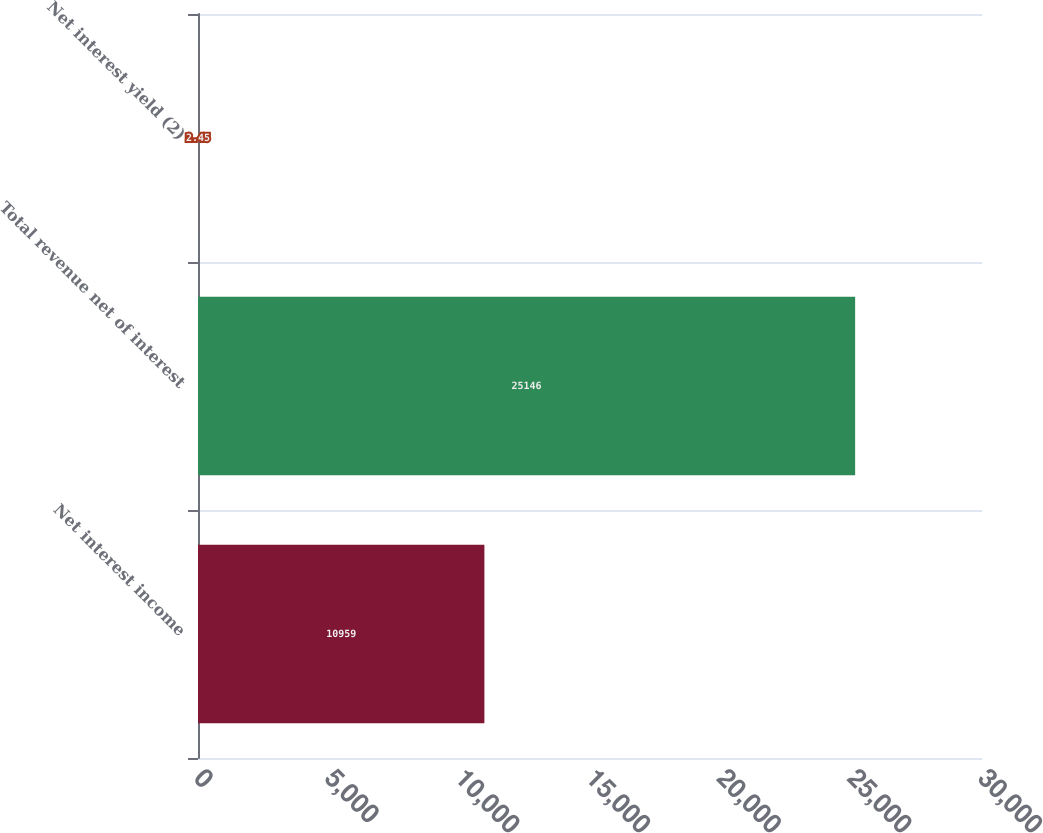Convert chart to OTSL. <chart><loc_0><loc_0><loc_500><loc_500><bar_chart><fcel>Net interest income<fcel>Total revenue net of interest<fcel>Net interest yield (2)<nl><fcel>10959<fcel>25146<fcel>2.45<nl></chart> 